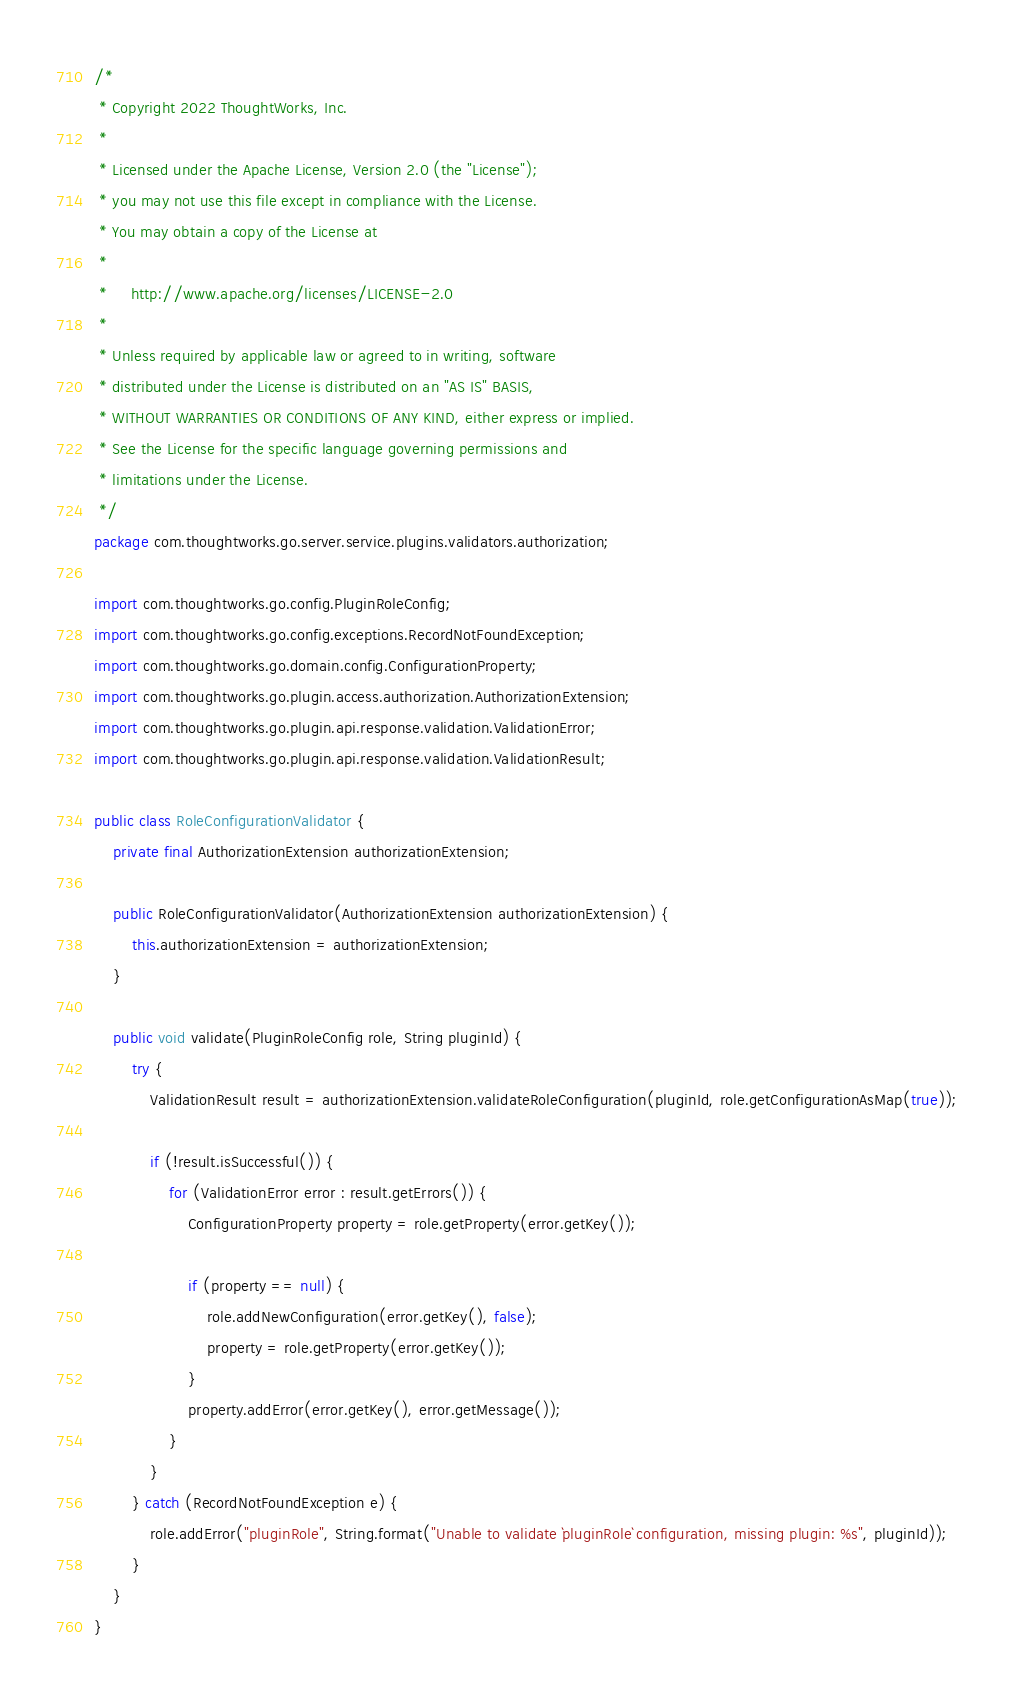Convert code to text. <code><loc_0><loc_0><loc_500><loc_500><_Java_>/*
 * Copyright 2022 ThoughtWorks, Inc.
 *
 * Licensed under the Apache License, Version 2.0 (the "License");
 * you may not use this file except in compliance with the License.
 * You may obtain a copy of the License at
 *
 *     http://www.apache.org/licenses/LICENSE-2.0
 *
 * Unless required by applicable law or agreed to in writing, software
 * distributed under the License is distributed on an "AS IS" BASIS,
 * WITHOUT WARRANTIES OR CONDITIONS OF ANY KIND, either express or implied.
 * See the License for the specific language governing permissions and
 * limitations under the License.
 */
package com.thoughtworks.go.server.service.plugins.validators.authorization;

import com.thoughtworks.go.config.PluginRoleConfig;
import com.thoughtworks.go.config.exceptions.RecordNotFoundException;
import com.thoughtworks.go.domain.config.ConfigurationProperty;
import com.thoughtworks.go.plugin.access.authorization.AuthorizationExtension;
import com.thoughtworks.go.plugin.api.response.validation.ValidationError;
import com.thoughtworks.go.plugin.api.response.validation.ValidationResult;

public class RoleConfigurationValidator {
    private final AuthorizationExtension authorizationExtension;

    public RoleConfigurationValidator(AuthorizationExtension authorizationExtension) {
        this.authorizationExtension = authorizationExtension;
    }

    public void validate(PluginRoleConfig role, String pluginId) {
        try {
            ValidationResult result = authorizationExtension.validateRoleConfiguration(pluginId, role.getConfigurationAsMap(true));

            if (!result.isSuccessful()) {
                for (ValidationError error : result.getErrors()) {
                    ConfigurationProperty property = role.getProperty(error.getKey());

                    if (property == null) {
                        role.addNewConfiguration(error.getKey(), false);
                        property = role.getProperty(error.getKey());
                    }
                    property.addError(error.getKey(), error.getMessage());
                }
            }
        } catch (RecordNotFoundException e) {
            role.addError("pluginRole", String.format("Unable to validate `pluginRole` configuration, missing plugin: %s", pluginId));
        }
    }
}
</code> 